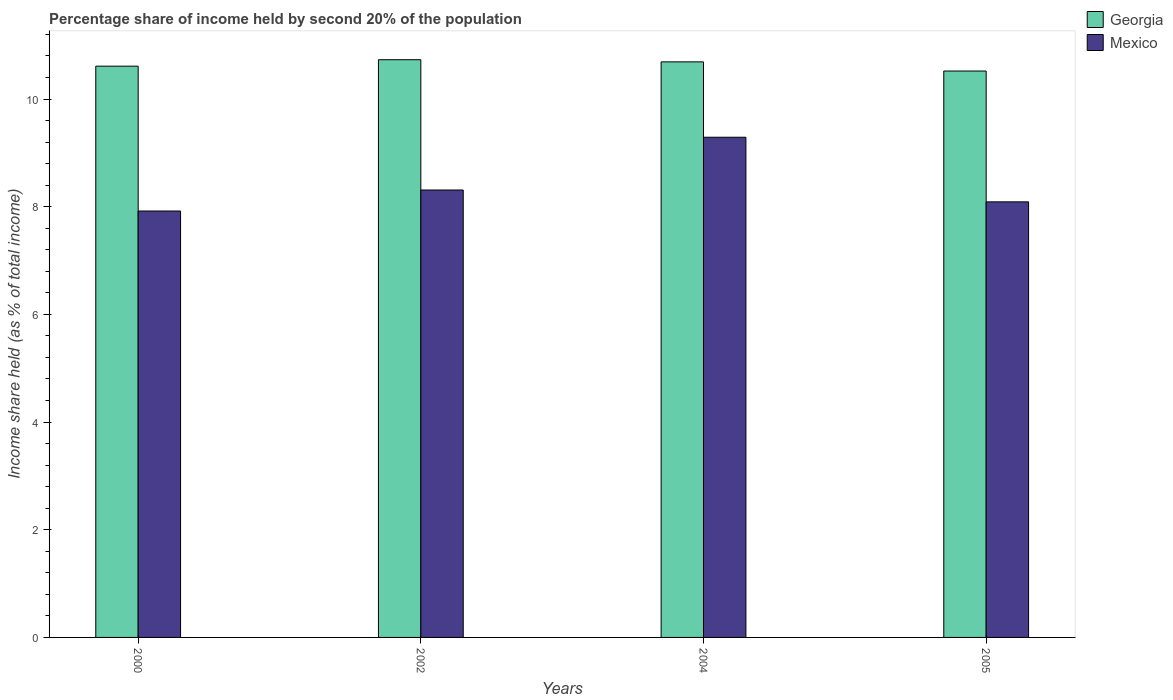How many different coloured bars are there?
Provide a short and direct response. 2. Are the number of bars per tick equal to the number of legend labels?
Provide a succinct answer. Yes. How many bars are there on the 4th tick from the left?
Offer a very short reply. 2. How many bars are there on the 2nd tick from the right?
Make the answer very short. 2. What is the label of the 3rd group of bars from the left?
Your answer should be compact. 2004. What is the share of income held by second 20% of the population in Georgia in 2004?
Give a very brief answer. 10.69. Across all years, what is the maximum share of income held by second 20% of the population in Mexico?
Give a very brief answer. 9.29. Across all years, what is the minimum share of income held by second 20% of the population in Georgia?
Offer a terse response. 10.52. In which year was the share of income held by second 20% of the population in Mexico minimum?
Provide a short and direct response. 2000. What is the total share of income held by second 20% of the population in Mexico in the graph?
Provide a short and direct response. 33.61. What is the difference between the share of income held by second 20% of the population in Georgia in 2000 and that in 2002?
Ensure brevity in your answer.  -0.12. What is the difference between the share of income held by second 20% of the population in Mexico in 2002 and the share of income held by second 20% of the population in Georgia in 2004?
Ensure brevity in your answer.  -2.38. What is the average share of income held by second 20% of the population in Mexico per year?
Make the answer very short. 8.4. In the year 2004, what is the difference between the share of income held by second 20% of the population in Georgia and share of income held by second 20% of the population in Mexico?
Keep it short and to the point. 1.4. What is the ratio of the share of income held by second 20% of the population in Mexico in 2000 to that in 2002?
Give a very brief answer. 0.95. Is the share of income held by second 20% of the population in Mexico in 2000 less than that in 2005?
Give a very brief answer. Yes. What is the difference between the highest and the second highest share of income held by second 20% of the population in Georgia?
Keep it short and to the point. 0.04. What is the difference between the highest and the lowest share of income held by second 20% of the population in Mexico?
Offer a terse response. 1.37. Is the sum of the share of income held by second 20% of the population in Georgia in 2000 and 2004 greater than the maximum share of income held by second 20% of the population in Mexico across all years?
Offer a very short reply. Yes. How many bars are there?
Your answer should be very brief. 8. What is the difference between two consecutive major ticks on the Y-axis?
Provide a short and direct response. 2. Are the values on the major ticks of Y-axis written in scientific E-notation?
Make the answer very short. No. Where does the legend appear in the graph?
Offer a very short reply. Top right. How are the legend labels stacked?
Provide a short and direct response. Vertical. What is the title of the graph?
Your answer should be very brief. Percentage share of income held by second 20% of the population. Does "Andorra" appear as one of the legend labels in the graph?
Your answer should be very brief. No. What is the label or title of the Y-axis?
Ensure brevity in your answer.  Income share held (as % of total income). What is the Income share held (as % of total income) in Georgia in 2000?
Your answer should be very brief. 10.61. What is the Income share held (as % of total income) in Mexico in 2000?
Give a very brief answer. 7.92. What is the Income share held (as % of total income) of Georgia in 2002?
Your response must be concise. 10.73. What is the Income share held (as % of total income) of Mexico in 2002?
Offer a very short reply. 8.31. What is the Income share held (as % of total income) of Georgia in 2004?
Provide a succinct answer. 10.69. What is the Income share held (as % of total income) of Mexico in 2004?
Keep it short and to the point. 9.29. What is the Income share held (as % of total income) of Georgia in 2005?
Make the answer very short. 10.52. What is the Income share held (as % of total income) in Mexico in 2005?
Make the answer very short. 8.09. Across all years, what is the maximum Income share held (as % of total income) of Georgia?
Give a very brief answer. 10.73. Across all years, what is the maximum Income share held (as % of total income) in Mexico?
Your response must be concise. 9.29. Across all years, what is the minimum Income share held (as % of total income) in Georgia?
Your response must be concise. 10.52. Across all years, what is the minimum Income share held (as % of total income) in Mexico?
Offer a very short reply. 7.92. What is the total Income share held (as % of total income) of Georgia in the graph?
Provide a succinct answer. 42.55. What is the total Income share held (as % of total income) in Mexico in the graph?
Your answer should be very brief. 33.61. What is the difference between the Income share held (as % of total income) in Georgia in 2000 and that in 2002?
Offer a terse response. -0.12. What is the difference between the Income share held (as % of total income) of Mexico in 2000 and that in 2002?
Your answer should be very brief. -0.39. What is the difference between the Income share held (as % of total income) of Georgia in 2000 and that in 2004?
Your response must be concise. -0.08. What is the difference between the Income share held (as % of total income) in Mexico in 2000 and that in 2004?
Your response must be concise. -1.37. What is the difference between the Income share held (as % of total income) of Georgia in 2000 and that in 2005?
Your response must be concise. 0.09. What is the difference between the Income share held (as % of total income) in Mexico in 2000 and that in 2005?
Ensure brevity in your answer.  -0.17. What is the difference between the Income share held (as % of total income) of Georgia in 2002 and that in 2004?
Keep it short and to the point. 0.04. What is the difference between the Income share held (as % of total income) of Mexico in 2002 and that in 2004?
Your answer should be compact. -0.98. What is the difference between the Income share held (as % of total income) in Georgia in 2002 and that in 2005?
Make the answer very short. 0.21. What is the difference between the Income share held (as % of total income) of Mexico in 2002 and that in 2005?
Your answer should be compact. 0.22. What is the difference between the Income share held (as % of total income) in Georgia in 2004 and that in 2005?
Make the answer very short. 0.17. What is the difference between the Income share held (as % of total income) in Georgia in 2000 and the Income share held (as % of total income) in Mexico in 2002?
Provide a succinct answer. 2.3. What is the difference between the Income share held (as % of total income) in Georgia in 2000 and the Income share held (as % of total income) in Mexico in 2004?
Your answer should be compact. 1.32. What is the difference between the Income share held (as % of total income) of Georgia in 2000 and the Income share held (as % of total income) of Mexico in 2005?
Offer a terse response. 2.52. What is the difference between the Income share held (as % of total income) in Georgia in 2002 and the Income share held (as % of total income) in Mexico in 2004?
Make the answer very short. 1.44. What is the difference between the Income share held (as % of total income) of Georgia in 2002 and the Income share held (as % of total income) of Mexico in 2005?
Your answer should be very brief. 2.64. What is the average Income share held (as % of total income) in Georgia per year?
Provide a short and direct response. 10.64. What is the average Income share held (as % of total income) of Mexico per year?
Provide a succinct answer. 8.4. In the year 2000, what is the difference between the Income share held (as % of total income) in Georgia and Income share held (as % of total income) in Mexico?
Provide a succinct answer. 2.69. In the year 2002, what is the difference between the Income share held (as % of total income) in Georgia and Income share held (as % of total income) in Mexico?
Make the answer very short. 2.42. In the year 2005, what is the difference between the Income share held (as % of total income) of Georgia and Income share held (as % of total income) of Mexico?
Give a very brief answer. 2.43. What is the ratio of the Income share held (as % of total income) of Georgia in 2000 to that in 2002?
Ensure brevity in your answer.  0.99. What is the ratio of the Income share held (as % of total income) in Mexico in 2000 to that in 2002?
Make the answer very short. 0.95. What is the ratio of the Income share held (as % of total income) of Georgia in 2000 to that in 2004?
Make the answer very short. 0.99. What is the ratio of the Income share held (as % of total income) of Mexico in 2000 to that in 2004?
Make the answer very short. 0.85. What is the ratio of the Income share held (as % of total income) of Georgia in 2000 to that in 2005?
Make the answer very short. 1.01. What is the ratio of the Income share held (as % of total income) in Georgia in 2002 to that in 2004?
Your answer should be very brief. 1. What is the ratio of the Income share held (as % of total income) of Mexico in 2002 to that in 2004?
Ensure brevity in your answer.  0.89. What is the ratio of the Income share held (as % of total income) in Mexico in 2002 to that in 2005?
Offer a very short reply. 1.03. What is the ratio of the Income share held (as % of total income) in Georgia in 2004 to that in 2005?
Provide a succinct answer. 1.02. What is the ratio of the Income share held (as % of total income) in Mexico in 2004 to that in 2005?
Offer a terse response. 1.15. What is the difference between the highest and the second highest Income share held (as % of total income) in Mexico?
Your response must be concise. 0.98. What is the difference between the highest and the lowest Income share held (as % of total income) of Georgia?
Make the answer very short. 0.21. What is the difference between the highest and the lowest Income share held (as % of total income) of Mexico?
Keep it short and to the point. 1.37. 